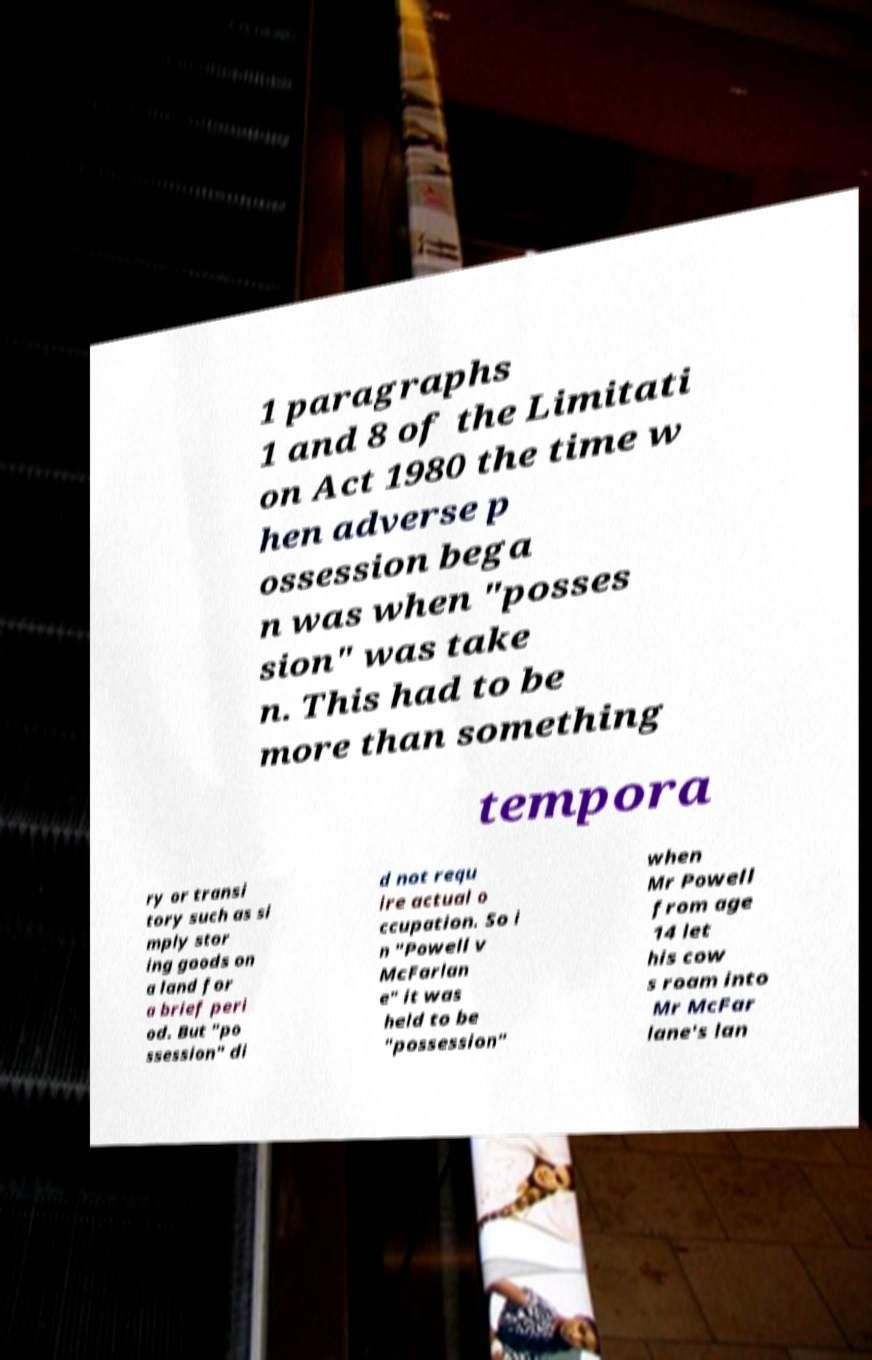Please read and relay the text visible in this image. What does it say? 1 paragraphs 1 and 8 of the Limitati on Act 1980 the time w hen adverse p ossession bega n was when "posses sion" was take n. This had to be more than something tempora ry or transi tory such as si mply stor ing goods on a land for a brief peri od. But "po ssession" di d not requ ire actual o ccupation. So i n "Powell v McFarlan e" it was held to be "possession" when Mr Powell from age 14 let his cow s roam into Mr McFar lane's lan 